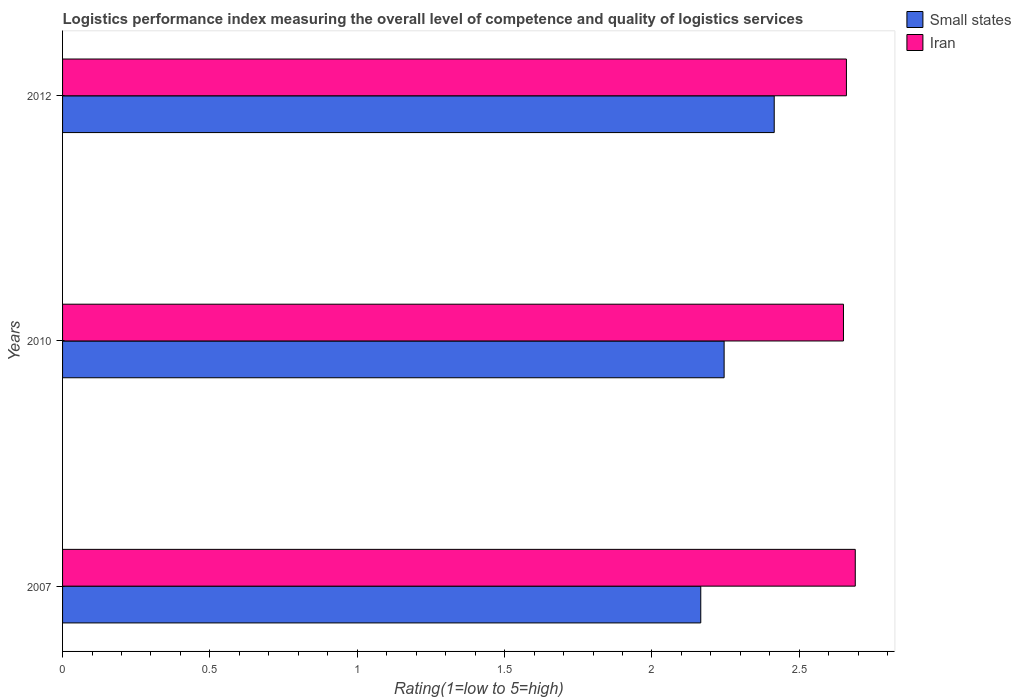How many different coloured bars are there?
Your response must be concise. 2. How many groups of bars are there?
Your response must be concise. 3. Are the number of bars on each tick of the Y-axis equal?
Your answer should be compact. Yes. How many bars are there on the 1st tick from the top?
Make the answer very short. 2. How many bars are there on the 3rd tick from the bottom?
Offer a very short reply. 2. In how many cases, is the number of bars for a given year not equal to the number of legend labels?
Your response must be concise. 0. What is the Logistic performance index in Iran in 2007?
Make the answer very short. 2.69. Across all years, what is the maximum Logistic performance index in Iran?
Offer a terse response. 2.69. Across all years, what is the minimum Logistic performance index in Iran?
Your answer should be very brief. 2.65. In which year was the Logistic performance index in Iran maximum?
Your answer should be compact. 2007. What is the total Logistic performance index in Small states in the graph?
Make the answer very short. 6.83. What is the difference between the Logistic performance index in Iran in 2010 and that in 2012?
Give a very brief answer. -0.01. What is the difference between the Logistic performance index in Small states in 2007 and the Logistic performance index in Iran in 2012?
Your answer should be very brief. -0.49. What is the average Logistic performance index in Iran per year?
Offer a terse response. 2.67. In the year 2010, what is the difference between the Logistic performance index in Iran and Logistic performance index in Small states?
Keep it short and to the point. 0.4. In how many years, is the Logistic performance index in Iran greater than 2.7 ?
Make the answer very short. 0. What is the ratio of the Logistic performance index in Iran in 2007 to that in 2012?
Your answer should be very brief. 1.01. Is the Logistic performance index in Iran in 2007 less than that in 2012?
Give a very brief answer. No. What is the difference between the highest and the second highest Logistic performance index in Iran?
Keep it short and to the point. 0.03. What is the difference between the highest and the lowest Logistic performance index in Small states?
Your response must be concise. 0.25. Is the sum of the Logistic performance index in Small states in 2010 and 2012 greater than the maximum Logistic performance index in Iran across all years?
Offer a terse response. Yes. What does the 2nd bar from the top in 2012 represents?
Your response must be concise. Small states. What does the 1st bar from the bottom in 2010 represents?
Give a very brief answer. Small states. How many bars are there?
Offer a very short reply. 6. Are the values on the major ticks of X-axis written in scientific E-notation?
Offer a terse response. No. Does the graph contain grids?
Your answer should be compact. No. How are the legend labels stacked?
Offer a very short reply. Vertical. What is the title of the graph?
Your answer should be compact. Logistics performance index measuring the overall level of competence and quality of logistics services. What is the label or title of the X-axis?
Your answer should be very brief. Rating(1=low to 5=high). What is the Rating(1=low to 5=high) in Small states in 2007?
Provide a succinct answer. 2.17. What is the Rating(1=low to 5=high) in Iran in 2007?
Provide a short and direct response. 2.69. What is the Rating(1=low to 5=high) in Small states in 2010?
Keep it short and to the point. 2.25. What is the Rating(1=low to 5=high) in Iran in 2010?
Provide a short and direct response. 2.65. What is the Rating(1=low to 5=high) of Small states in 2012?
Your answer should be very brief. 2.42. What is the Rating(1=low to 5=high) of Iran in 2012?
Your answer should be compact. 2.66. Across all years, what is the maximum Rating(1=low to 5=high) in Small states?
Your response must be concise. 2.42. Across all years, what is the maximum Rating(1=low to 5=high) in Iran?
Provide a succinct answer. 2.69. Across all years, what is the minimum Rating(1=low to 5=high) of Small states?
Provide a succinct answer. 2.17. Across all years, what is the minimum Rating(1=low to 5=high) of Iran?
Your answer should be compact. 2.65. What is the total Rating(1=low to 5=high) in Small states in the graph?
Provide a short and direct response. 6.83. What is the difference between the Rating(1=low to 5=high) of Small states in 2007 and that in 2010?
Provide a short and direct response. -0.08. What is the difference between the Rating(1=low to 5=high) in Small states in 2007 and that in 2012?
Provide a succinct answer. -0.25. What is the difference between the Rating(1=low to 5=high) in Iran in 2007 and that in 2012?
Keep it short and to the point. 0.03. What is the difference between the Rating(1=low to 5=high) in Small states in 2010 and that in 2012?
Provide a succinct answer. -0.17. What is the difference between the Rating(1=low to 5=high) of Iran in 2010 and that in 2012?
Your answer should be very brief. -0.01. What is the difference between the Rating(1=low to 5=high) of Small states in 2007 and the Rating(1=low to 5=high) of Iran in 2010?
Offer a terse response. -0.48. What is the difference between the Rating(1=low to 5=high) of Small states in 2007 and the Rating(1=low to 5=high) of Iran in 2012?
Keep it short and to the point. -0.49. What is the difference between the Rating(1=low to 5=high) in Small states in 2010 and the Rating(1=low to 5=high) in Iran in 2012?
Your response must be concise. -0.41. What is the average Rating(1=low to 5=high) in Small states per year?
Give a very brief answer. 2.28. What is the average Rating(1=low to 5=high) of Iran per year?
Provide a short and direct response. 2.67. In the year 2007, what is the difference between the Rating(1=low to 5=high) in Small states and Rating(1=low to 5=high) in Iran?
Your answer should be compact. -0.52. In the year 2010, what is the difference between the Rating(1=low to 5=high) of Small states and Rating(1=low to 5=high) of Iran?
Provide a succinct answer. -0.41. In the year 2012, what is the difference between the Rating(1=low to 5=high) in Small states and Rating(1=low to 5=high) in Iran?
Ensure brevity in your answer.  -0.24. What is the ratio of the Rating(1=low to 5=high) of Small states in 2007 to that in 2010?
Provide a succinct answer. 0.96. What is the ratio of the Rating(1=low to 5=high) in Iran in 2007 to that in 2010?
Your answer should be compact. 1.02. What is the ratio of the Rating(1=low to 5=high) of Small states in 2007 to that in 2012?
Offer a terse response. 0.9. What is the ratio of the Rating(1=low to 5=high) in Iran in 2007 to that in 2012?
Offer a very short reply. 1.01. What is the ratio of the Rating(1=low to 5=high) in Small states in 2010 to that in 2012?
Ensure brevity in your answer.  0.93. What is the difference between the highest and the second highest Rating(1=low to 5=high) in Small states?
Offer a very short reply. 0.17. What is the difference between the highest and the lowest Rating(1=low to 5=high) in Small states?
Give a very brief answer. 0.25. What is the difference between the highest and the lowest Rating(1=low to 5=high) of Iran?
Keep it short and to the point. 0.04. 